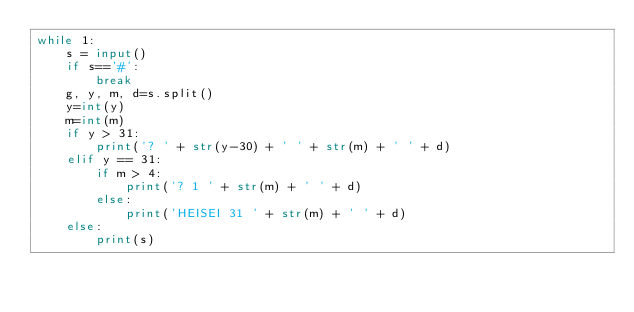<code> <loc_0><loc_0><loc_500><loc_500><_Python_>while 1:
    s = input()
    if s=='#':
        break
    g, y, m, d=s.split()
    y=int(y)
    m=int(m)
    if y > 31:
        print('? ' + str(y-30) + ' ' + str(m) + ' ' + d)
    elif y == 31:
        if m > 4:
            print('? 1 ' + str(m) + ' ' + d)
        else:
            print('HEISEI 31 ' + str(m) + ' ' + d)
    else:
        print(s)
</code> 